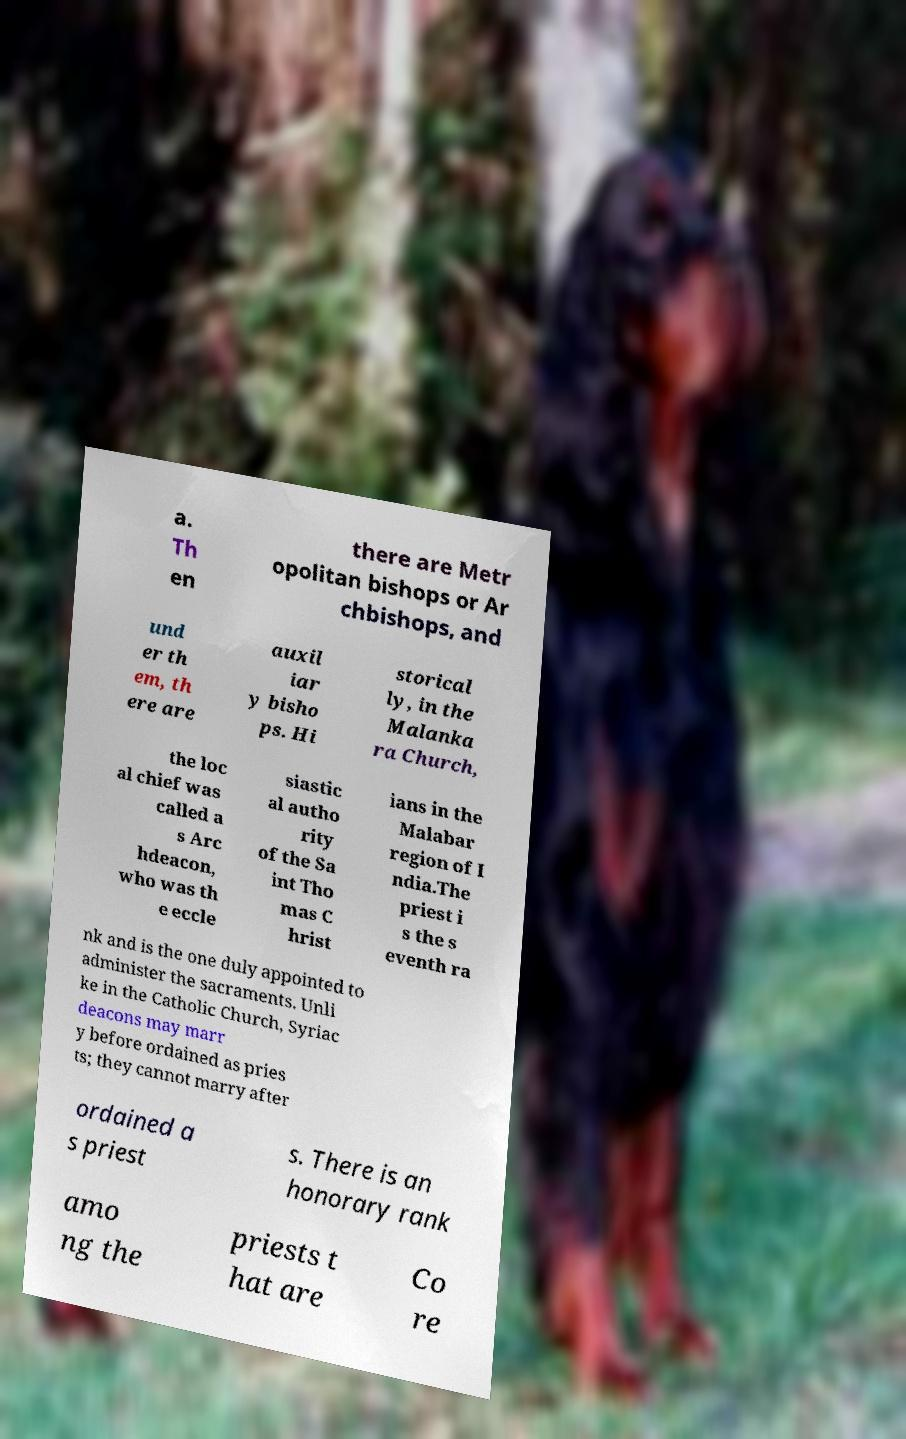Could you assist in decoding the text presented in this image and type it out clearly? a. Th en there are Metr opolitan bishops or Ar chbishops, and und er th em, th ere are auxil iar y bisho ps. Hi storical ly, in the Malanka ra Church, the loc al chief was called a s Arc hdeacon, who was th e eccle siastic al autho rity of the Sa int Tho mas C hrist ians in the Malabar region of I ndia.The priest i s the s eventh ra nk and is the one duly appointed to administer the sacraments. Unli ke in the Catholic Church, Syriac deacons may marr y before ordained as pries ts; they cannot marry after ordained a s priest s. There is an honorary rank amo ng the priests t hat are Co re 